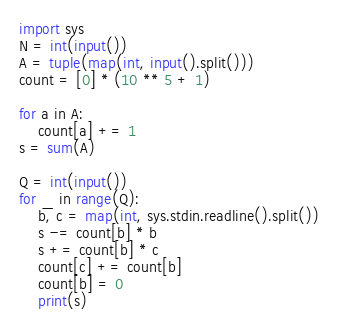Convert code to text. <code><loc_0><loc_0><loc_500><loc_500><_Python_>import sys
N = int(input())
A = tuple(map(int, input().split()))
count = [0] * (10 ** 5 + 1)

for a in A:
    count[a] += 1
s = sum(A)

Q = int(input())
for _ in range(Q):
    b, c = map(int, sys.stdin.readline().split())
    s -= count[b] * b
    s += count[b] * c
    count[c] += count[b]
    count[b] = 0
    print(s)</code> 